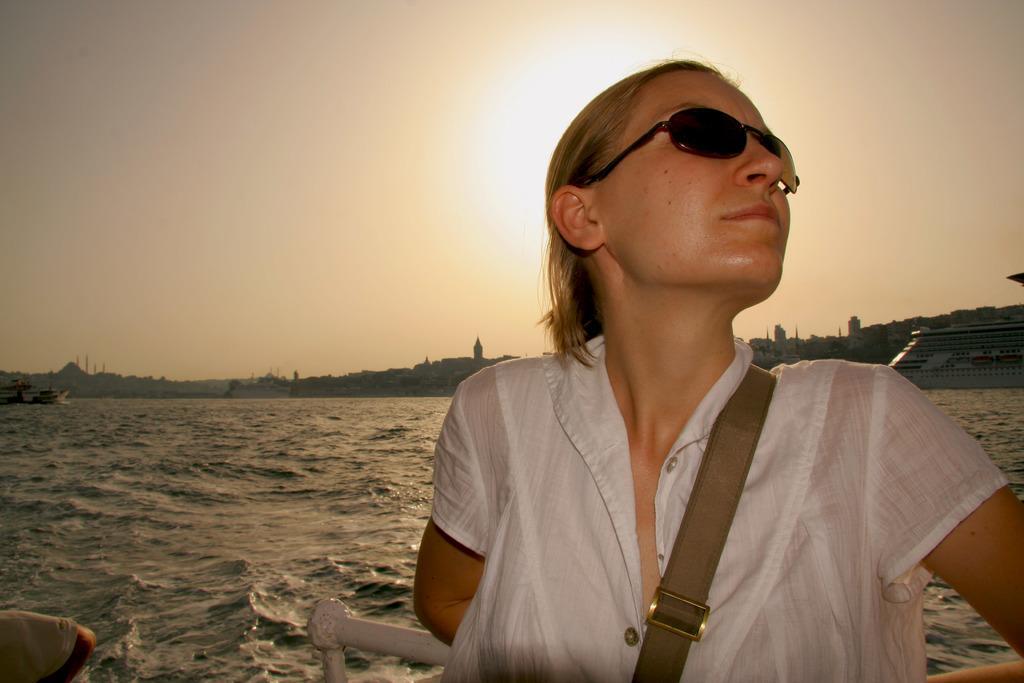Could you give a brief overview of what you see in this image? In the center of the image there is a woman wearing spectacles. In the background we can see water, buildings, ship and sky. 